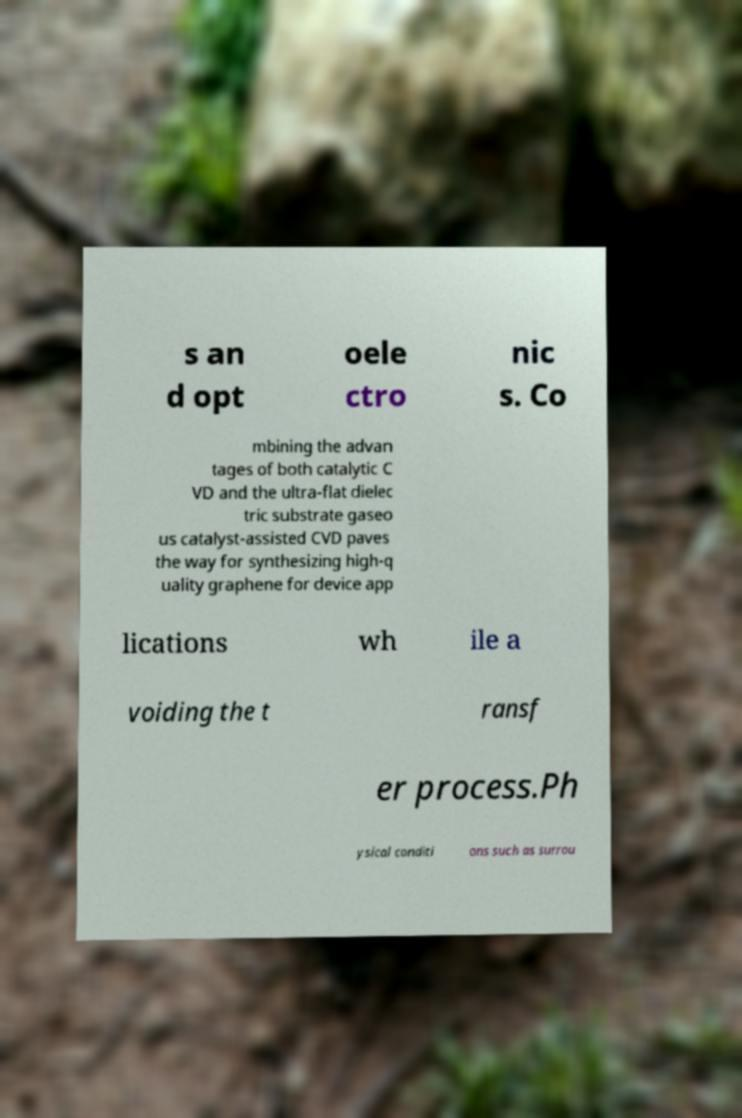Please read and relay the text visible in this image. What does it say? s an d opt oele ctro nic s. Co mbining the advan tages of both catalytic C VD and the ultra-flat dielec tric substrate gaseo us catalyst-assisted CVD paves the way for synthesizing high-q uality graphene for device app lications wh ile a voiding the t ransf er process.Ph ysical conditi ons such as surrou 